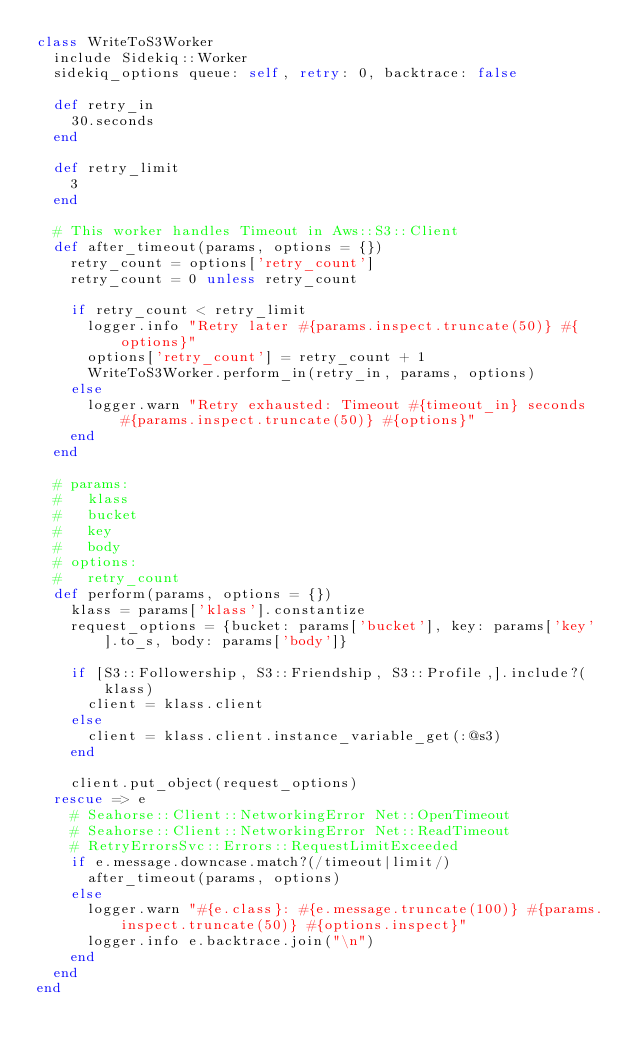<code> <loc_0><loc_0><loc_500><loc_500><_Ruby_>class WriteToS3Worker
  include Sidekiq::Worker
  sidekiq_options queue: self, retry: 0, backtrace: false

  def retry_in
    30.seconds
  end

  def retry_limit
    3
  end

  # This worker handles Timeout in Aws::S3::Client
  def after_timeout(params, options = {})
    retry_count = options['retry_count']
    retry_count = 0 unless retry_count

    if retry_count < retry_limit
      logger.info "Retry later #{params.inspect.truncate(50)} #{options}"
      options['retry_count'] = retry_count + 1
      WriteToS3Worker.perform_in(retry_in, params, options)
    else
      logger.warn "Retry exhausted: Timeout #{timeout_in} seconds #{params.inspect.truncate(50)} #{options}"
    end
  end

  # params:
  #   klass
  #   bucket
  #   key
  #   body
  # options:
  #   retry_count
  def perform(params, options = {})
    klass = params['klass'].constantize
    request_options = {bucket: params['bucket'], key: params['key'].to_s, body: params['body']}

    if [S3::Followership, S3::Friendship, S3::Profile,].include?(klass)
      client = klass.client
    else
      client = klass.client.instance_variable_get(:@s3)
    end

    client.put_object(request_options)
  rescue => e
    # Seahorse::Client::NetworkingError Net::OpenTimeout
    # Seahorse::Client::NetworkingError Net::ReadTimeout
    # RetryErrorsSvc::Errors::RequestLimitExceeded
    if e.message.downcase.match?(/timeout|limit/)
      after_timeout(params, options)
    else
      logger.warn "#{e.class}: #{e.message.truncate(100)} #{params.inspect.truncate(50)} #{options.inspect}"
      logger.info e.backtrace.join("\n")
    end
  end
end
</code> 